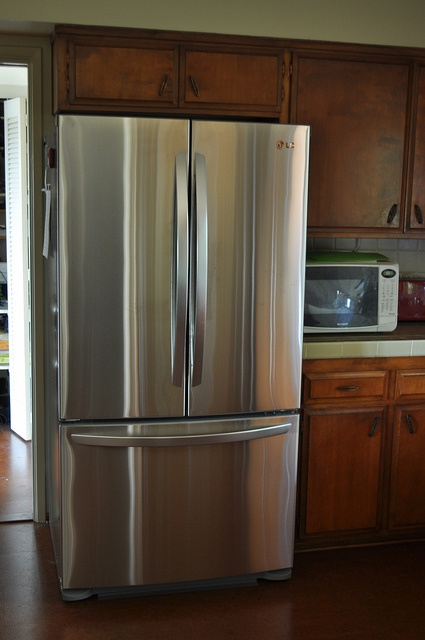Describe the objects in this image and their specific colors. I can see refrigerator in gray and black tones and microwave in gray, black, darkgray, and purple tones in this image. 